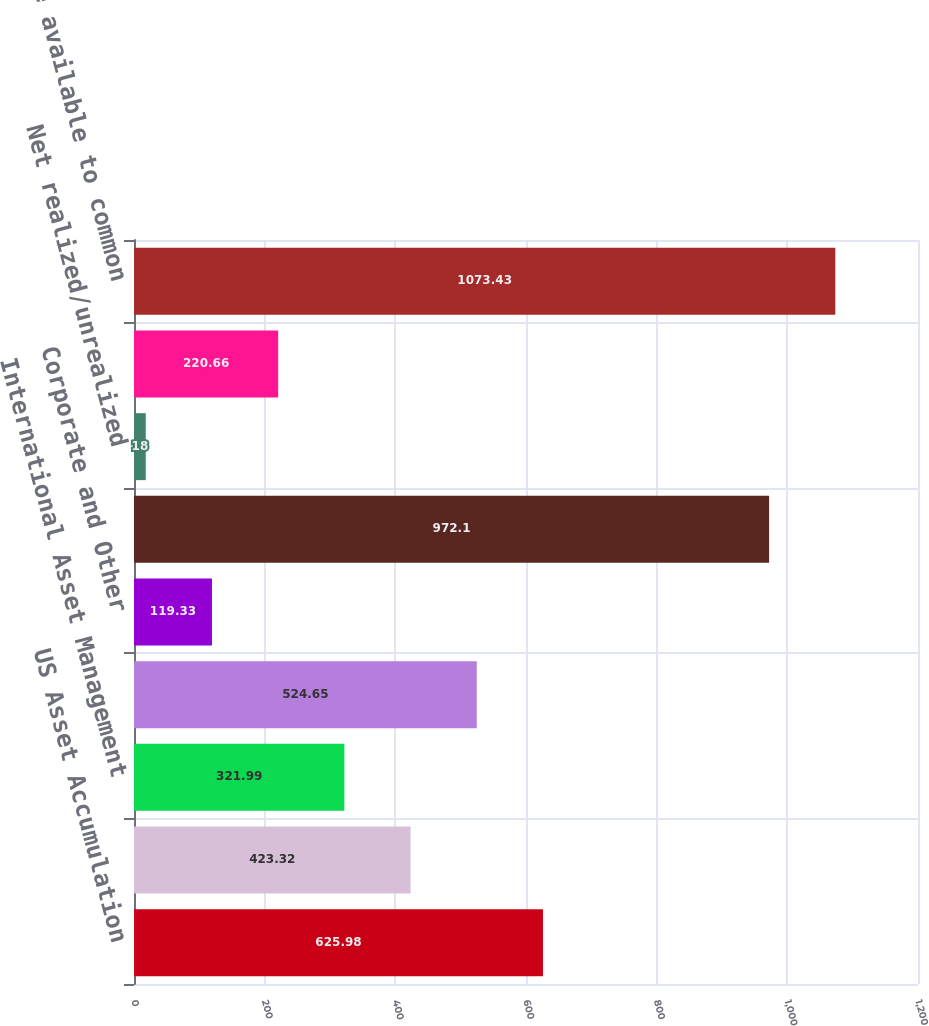<chart> <loc_0><loc_0><loc_500><loc_500><bar_chart><fcel>US Asset Accumulation<fcel>Global Asset Management<fcel>International Asset Management<fcel>Life and Health Insurance<fcel>Corporate and Other<fcel>Total segment operating<fcel>Net realized/unrealized<fcel>Other after-tax adjustments<fcel>Net income available to common<nl><fcel>625.98<fcel>423.32<fcel>321.99<fcel>524.65<fcel>119.33<fcel>972.1<fcel>18<fcel>220.66<fcel>1073.43<nl></chart> 